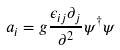<formula> <loc_0><loc_0><loc_500><loc_500>a _ { i } = g \frac { \epsilon _ { i j } \partial _ { j } } { \partial ^ { 2 } } \psi ^ { \dagger } \psi</formula> 